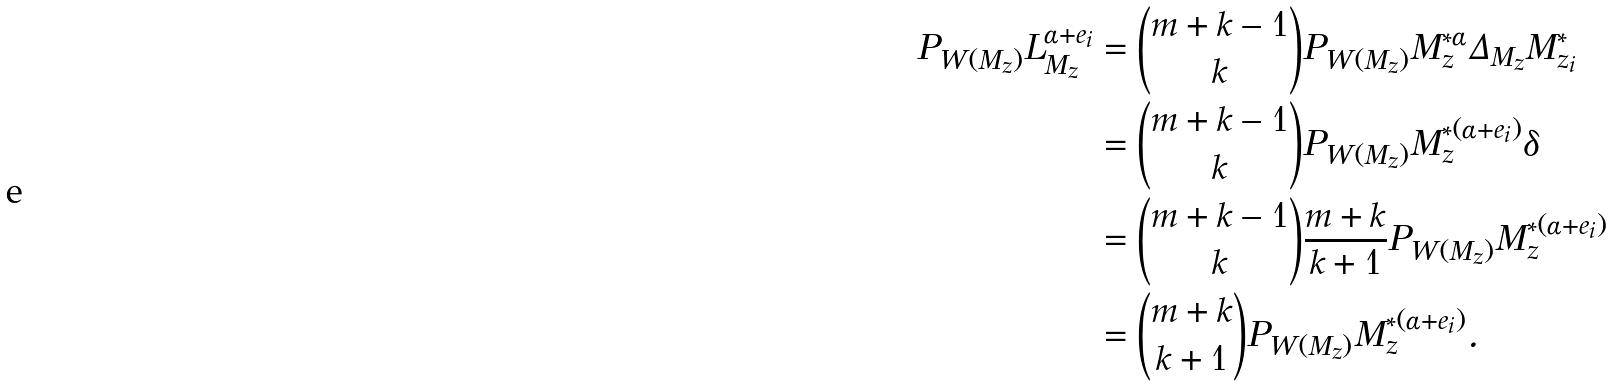<formula> <loc_0><loc_0><loc_500><loc_500>P _ { W ( M _ { z } ) } L ^ { \alpha + e _ { i } } _ { M _ { z } } & = \binom { m + k - 1 } { k } P _ { W ( M _ { z } ) } M _ { z } ^ { * \alpha } \Delta _ { M _ { z } } M ^ { * } _ { z _ { i } } \\ & = \binom { m + k - 1 } { k } P _ { W ( M _ { z } ) } M _ { z } ^ { * ( \alpha + e _ { i } ) } \delta \\ & = \binom { m + k - 1 } { k } \frac { m + k } { k + 1 } P _ { W ( M _ { z } ) } M _ { z } ^ { * ( \alpha + e _ { i } ) } \\ & = \binom { m + k } { k + 1 } P _ { W ( M _ { z } ) } M _ { z } ^ { * ( \alpha + e _ { i } ) } .</formula> 